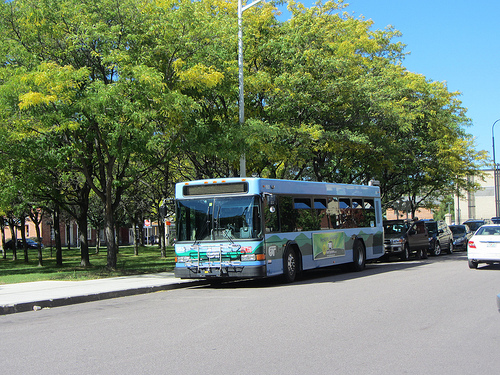Is the color of the bus the sharegpt4v/same as the sky? Yes, the color of the bus closely matches the blue sky. 